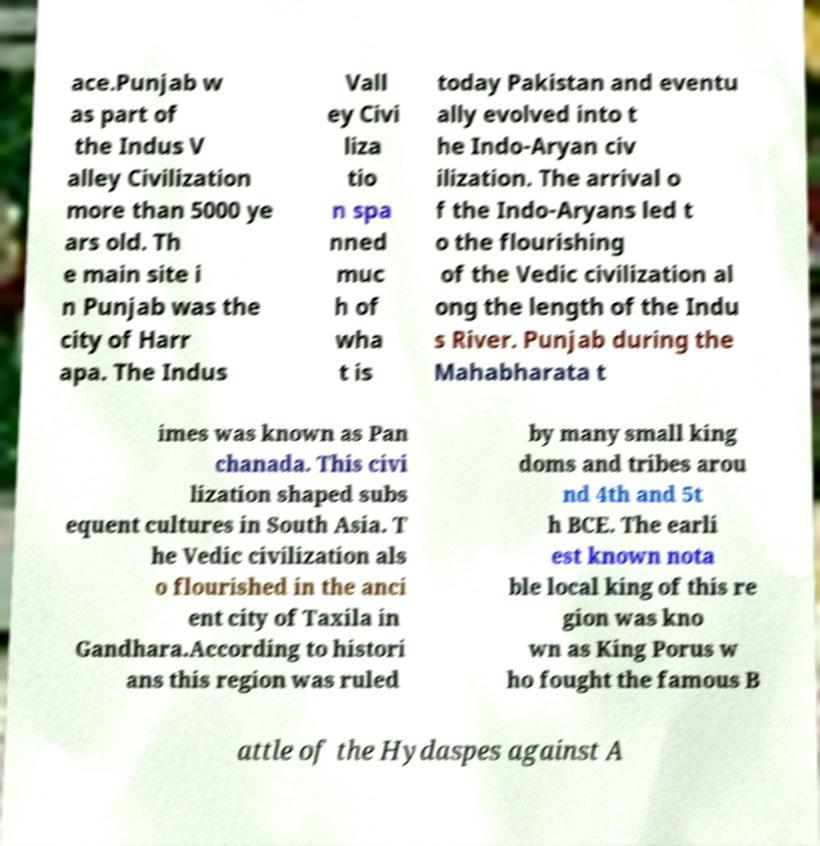Please identify and transcribe the text found in this image. ace.Punjab w as part of the Indus V alley Civilization more than 5000 ye ars old. Th e main site i n Punjab was the city of Harr apa. The Indus Vall ey Civi liza tio n spa nned muc h of wha t is today Pakistan and eventu ally evolved into t he Indo-Aryan civ ilization. The arrival o f the Indo-Aryans led t o the flourishing of the Vedic civilization al ong the length of the Indu s River. Punjab during the Mahabharata t imes was known as Pan chanada. This civi lization shaped subs equent cultures in South Asia. T he Vedic civilization als o flourished in the anci ent city of Taxila in Gandhara.According to histori ans this region was ruled by many small king doms and tribes arou nd 4th and 5t h BCE. The earli est known nota ble local king of this re gion was kno wn as King Porus w ho fought the famous B attle of the Hydaspes against A 